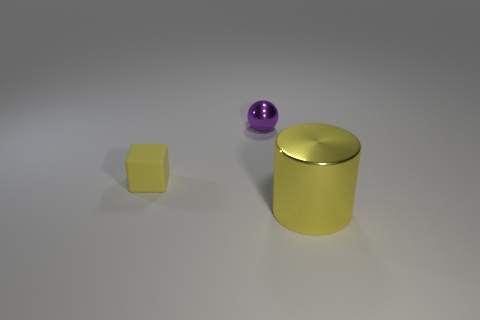Subtract all red blocks. Subtract all red cylinders. How many blocks are left? 1 Add 1 purple matte cubes. How many objects exist? 4 Subtract all spheres. How many objects are left? 2 Add 3 purple spheres. How many purple spheres are left? 4 Add 2 cubes. How many cubes exist? 3 Subtract 1 purple spheres. How many objects are left? 2 Subtract all large yellow things. Subtract all yellow rubber blocks. How many objects are left? 1 